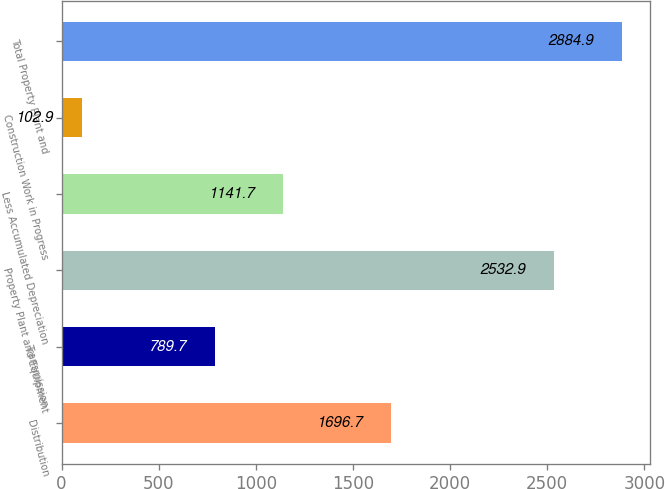Convert chart to OTSL. <chart><loc_0><loc_0><loc_500><loc_500><bar_chart><fcel>Distribution<fcel>Transmission<fcel>Property Plant and Equipment<fcel>Less Accumulated Depreciation<fcel>Construction Work in Progress<fcel>Total Property Plant and<nl><fcel>1696.7<fcel>789.7<fcel>2532.9<fcel>1141.7<fcel>102.9<fcel>2884.9<nl></chart> 